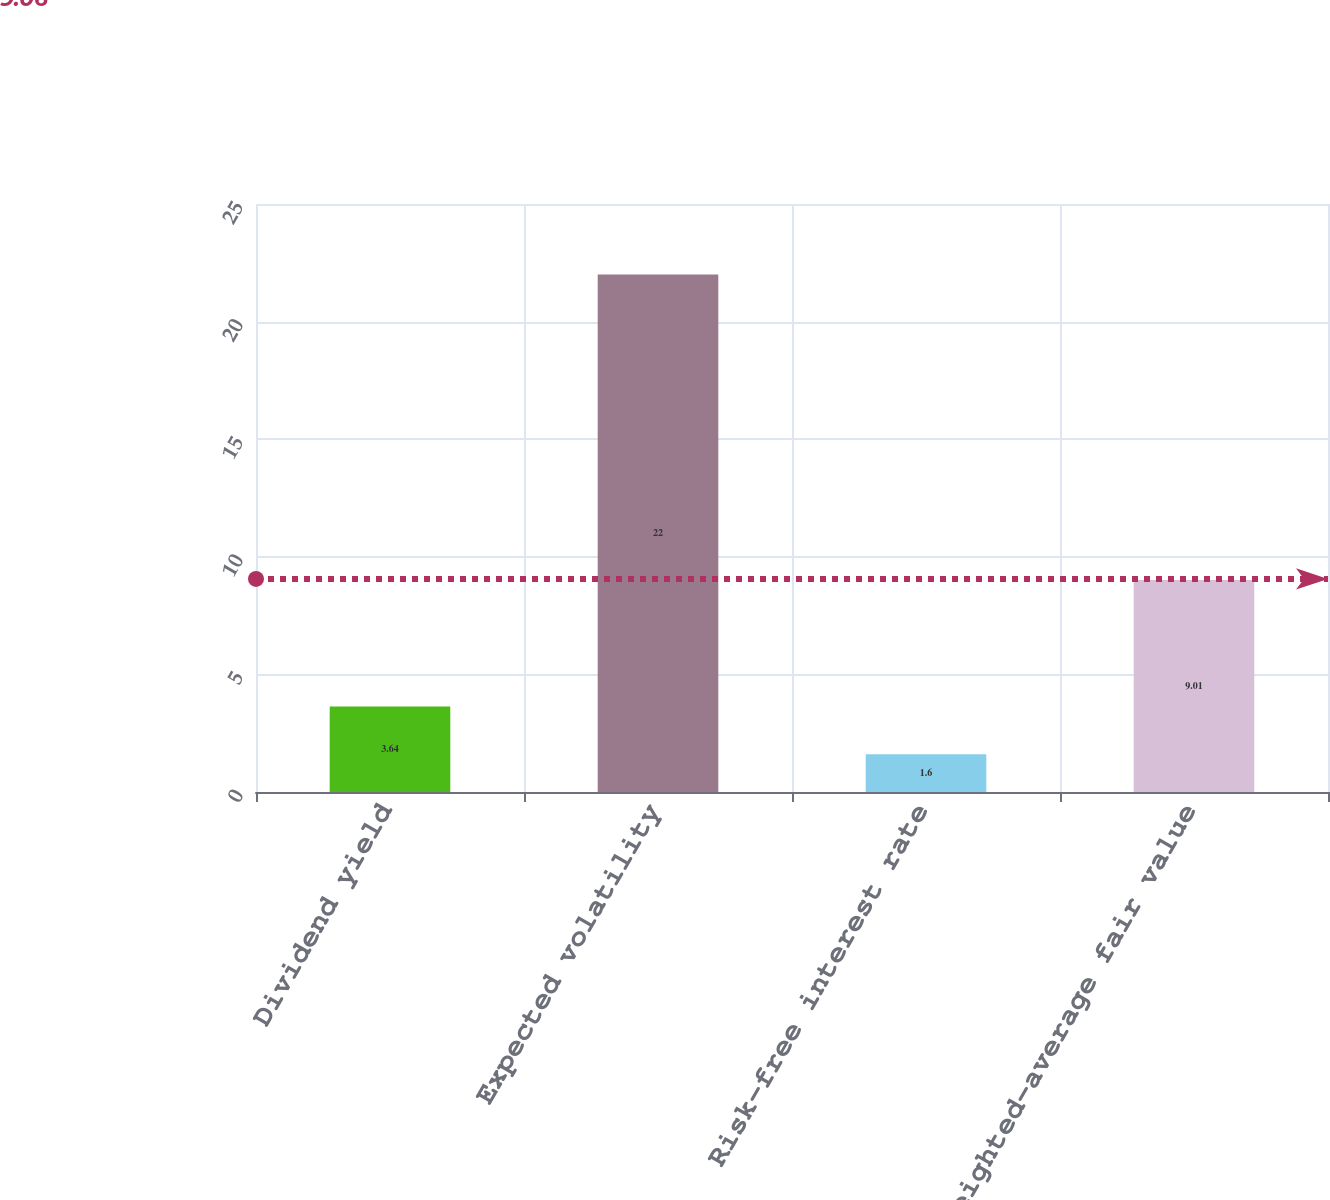Convert chart. <chart><loc_0><loc_0><loc_500><loc_500><bar_chart><fcel>Dividend yield<fcel>Expected volatility<fcel>Risk-free interest rate<fcel>Weighted-average fair value<nl><fcel>3.64<fcel>22<fcel>1.6<fcel>9.01<nl></chart> 